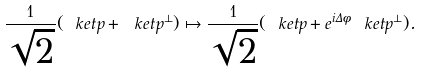<formula> <loc_0><loc_0><loc_500><loc_500>\frac { 1 } { \sqrt { 2 } } ( \ k e t { p } + \ k e t { p ^ { \perp } } ) \mapsto \frac { 1 } { \sqrt { 2 } } ( \ k e t { p } + e ^ { i \Delta \phi } \ k e t { p ^ { \perp } } ) .</formula> 